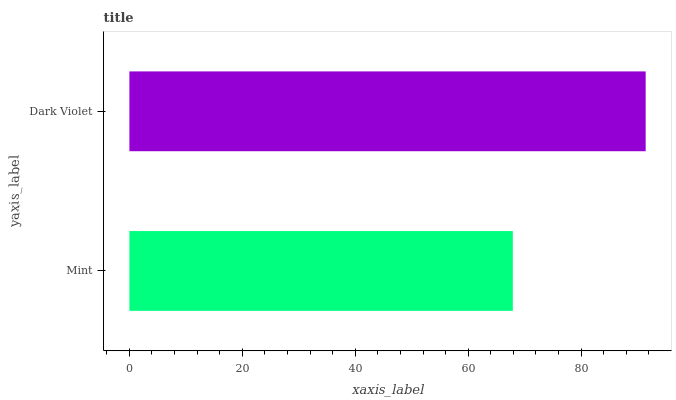Is Mint the minimum?
Answer yes or no. Yes. Is Dark Violet the maximum?
Answer yes or no. Yes. Is Dark Violet the minimum?
Answer yes or no. No. Is Dark Violet greater than Mint?
Answer yes or no. Yes. Is Mint less than Dark Violet?
Answer yes or no. Yes. Is Mint greater than Dark Violet?
Answer yes or no. No. Is Dark Violet less than Mint?
Answer yes or no. No. Is Dark Violet the high median?
Answer yes or no. Yes. Is Mint the low median?
Answer yes or no. Yes. Is Mint the high median?
Answer yes or no. No. Is Dark Violet the low median?
Answer yes or no. No. 